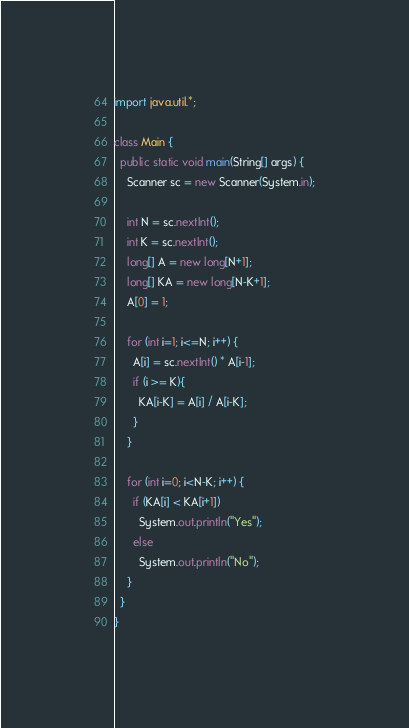<code> <loc_0><loc_0><loc_500><loc_500><_Java_>import java.util.*;
 
class Main {
  public static void main(String[] args) {
	Scanner sc = new Scanner(System.in);
    
    int N = sc.nextInt();
    int K = sc.nextInt();
    long[] A = new long[N+1];
    long[] KA = new long[N-K+1];
	A[0] = 1;
    
    for (int i=1; i<=N; i++) {
      A[i] = sc.nextInt() * A[i-1];
      if (i >= K){
      	KA[i-K] = A[i] / A[i-K];
      }
    }
    
    for (int i=0; i<N-K; i++) {
	  if (KA[i] < KA[i+1])
        System.out.println("Yes");
      else
        System.out.println("No");
    }
  }
}</code> 